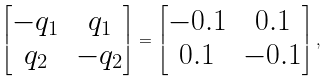<formula> <loc_0><loc_0><loc_500><loc_500>\begin{bmatrix} - q _ { 1 } & q _ { 1 } \\ q _ { 2 } & - q _ { 2 } \end{bmatrix} = \begin{bmatrix} - 0 . 1 & 0 . 1 \\ 0 . 1 & - 0 . 1 \end{bmatrix} ,</formula> 